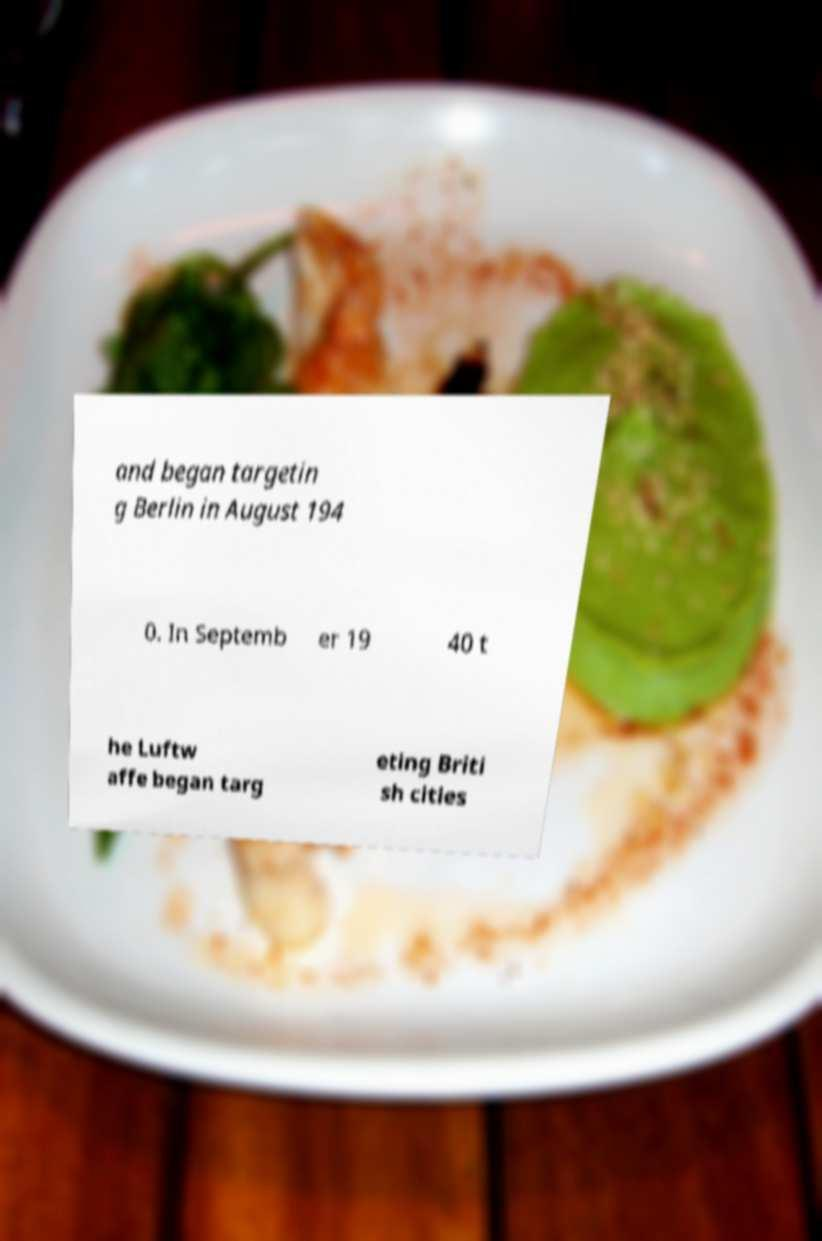Can you read and provide the text displayed in the image?This photo seems to have some interesting text. Can you extract and type it out for me? and began targetin g Berlin in August 194 0. In Septemb er 19 40 t he Luftw affe began targ eting Briti sh cities 